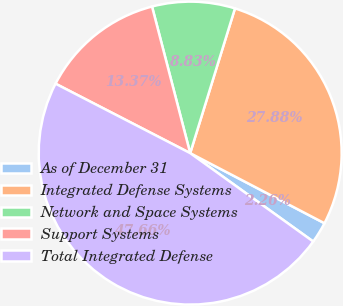Convert chart to OTSL. <chart><loc_0><loc_0><loc_500><loc_500><pie_chart><fcel>As of December 31<fcel>Integrated Defense Systems<fcel>Network and Space Systems<fcel>Support Systems<fcel>Total Integrated Defense<nl><fcel>2.26%<fcel>27.88%<fcel>8.83%<fcel>13.37%<fcel>47.66%<nl></chart> 